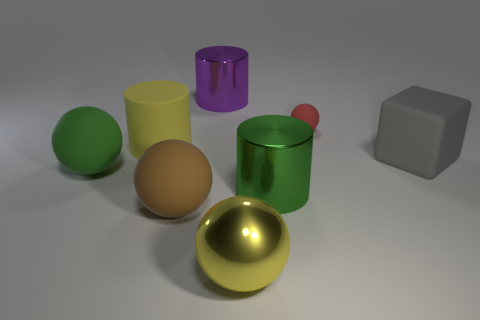Can you describe the colors and shapes of objects present in this image? Certainly! The image displays a range of objects with different colors and shapes. There's a shiny yellow sphere, a matte green cylinder, a metallic purple cylinder, a matte brown sphere, and a light gray cube. Additionally, there is a shiny red sphere and a matte beige sphere, completing the collection of various geometric forms and hues. 